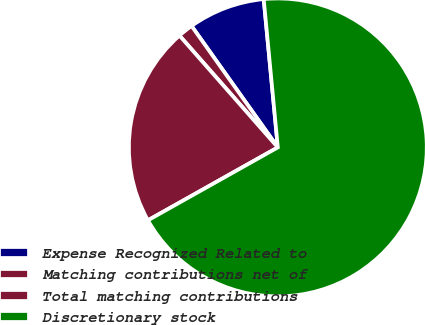<chart> <loc_0><loc_0><loc_500><loc_500><pie_chart><fcel>Expense Recognized Related to<fcel>Matching contributions net of<fcel>Total matching contributions<fcel>Discretionary stock<nl><fcel>8.32%<fcel>1.65%<fcel>21.66%<fcel>68.37%<nl></chart> 